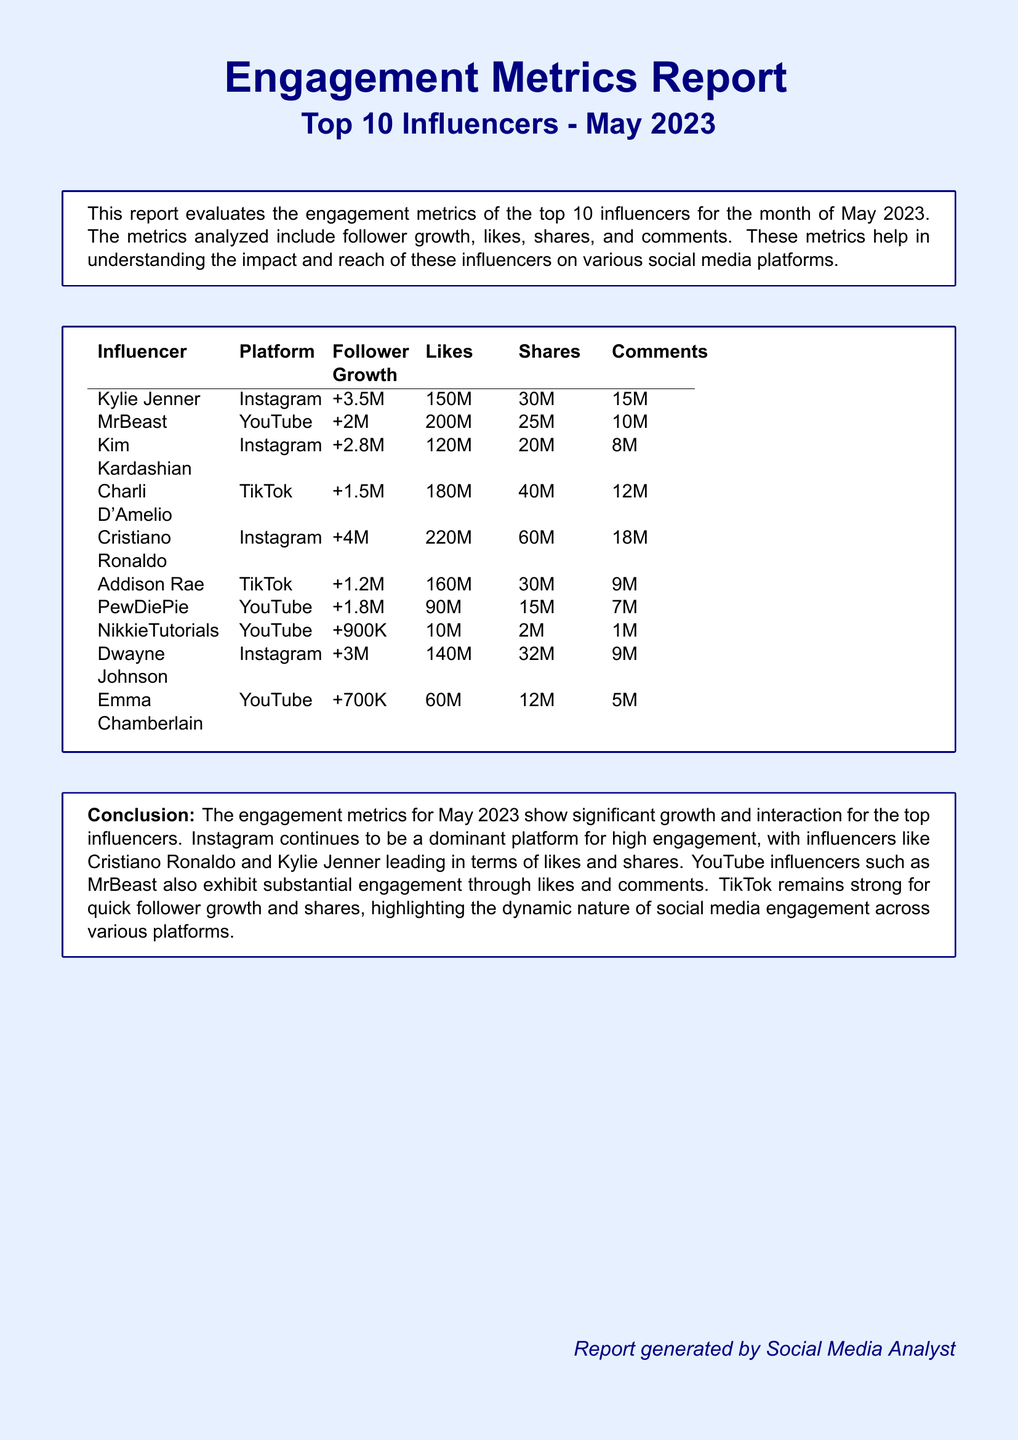What is the top influencer by follower growth? Cristiano Ronaldo has the highest follower growth among the listed influencers, with +4M followers.
Answer: Cristiano Ronaldo How many likes did MrBeast receive? MrBeast's total likes are indicated in the table as 200M.
Answer: 200M Which platform had the highest engagement for Kylie Jenner? The table shows that Kylie Jenner's highest engagement metrics were on Instagram.
Answer: Instagram What is the total number of shares for Charli D'Amelio? Charli D'Amelio's shares are listed as 40M in the report.
Answer: 40M Which influencer has the lowest follower growth? NikkieTutorials has the least follower growth, with +900K followers.
Answer: NikkieTutorials How many comments did Dwayne Johnson receive? Dwayne Johnson's comments are presented in the report as 9M.
Answer: 9M What does the conclusion suggest about Instagram influencers? The conclusion emphasizes Instagram as a leading platform for high engagement from influencers like Cristiano Ronaldo and Kylie Jenner.
Answer: Dominant platform Which influencer had the highest number of shares? Cristiano Ronaldo had the most shares, with 60M.
Answer: Cristiano Ronaldo What is the total engagement (likes, shares, comments) for Kim Kardashian? The total engagement combines Kim Kardashian's likes (120M), shares (20M), and comments (8M), resulting in 148M.
Answer: 148M 